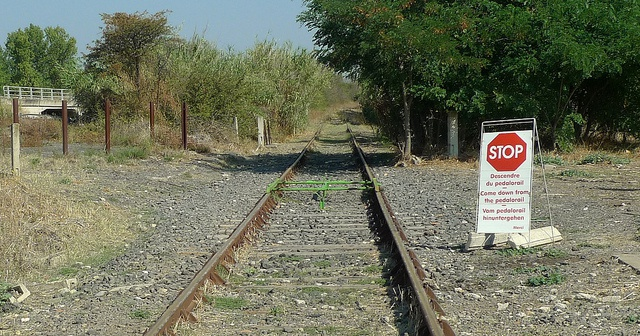Describe the objects in this image and their specific colors. I can see a stop sign in lightblue, brown, and ivory tones in this image. 